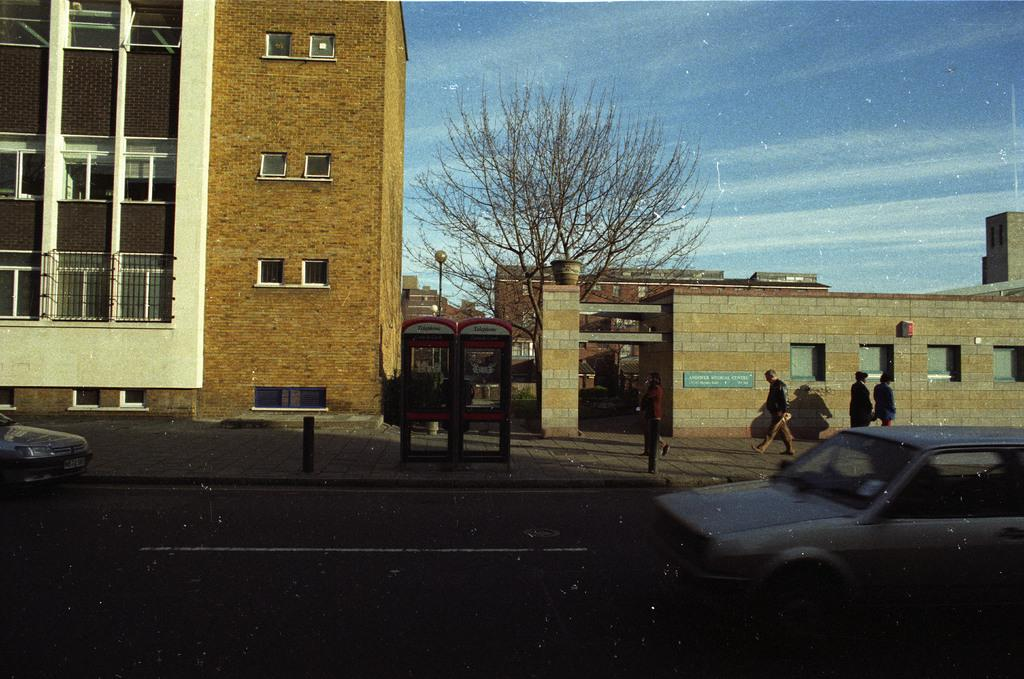What type of building is in the image? There is a brown building in the image. What is the condition of the tree in the image? There is a dry tree in the image. What can be seen on the road in the image? There are cars on the road in the image. What season is depicted in the image? The provided facts do not mention any seasonal details, so it cannot be determined from the image. How does the front of the building increase in size in the image? The front of the building does not increase in size in the image; it remains the same. 